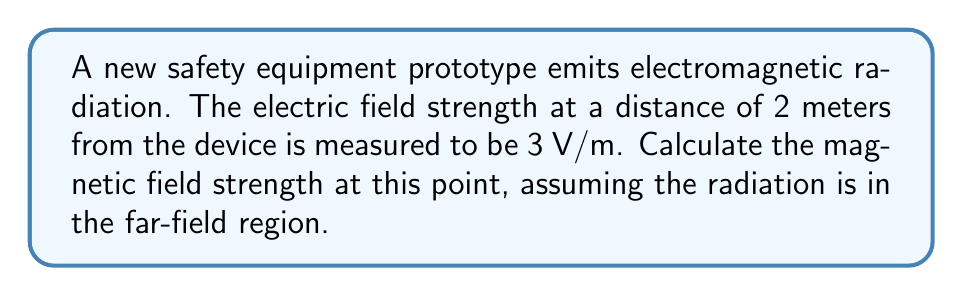Can you solve this math problem? To solve this problem, we'll use the relationship between electric and magnetic field strengths in the far-field region of electromagnetic radiation. The steps are as follows:

1) In the far-field region, the electric field $E$ and magnetic field $B$ are related by the speed of light $c$:

   $$E = cB$$

2) We know the speed of light is approximately $3 \times 10^8$ m/s.

3) We are given the electric field strength $E = 3$ V/m.

4) Rearranging the equation to solve for $B$:

   $$B = \frac{E}{c}$$

5) Substituting the values:

   $$B = \frac{3 \text{ V/m}}{3 \times 10^8 \text{ m/s}}$$

6) Simplifying:

   $$B = 1 \times 10^{-8} \text{ T}$$

7) Convert to more appropriate units (nT):

   $$B = 10 \text{ nT}$$
Answer: $10 \text{ nT}$ 